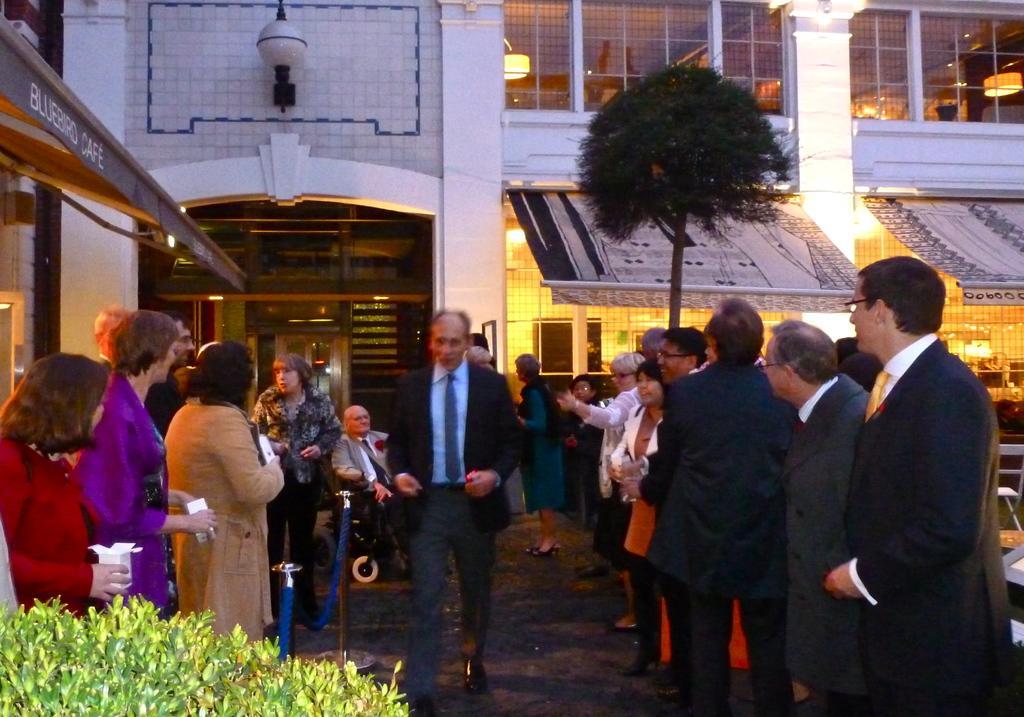Please provide a concise description of this image. In this picture we can see a group of people standing on the ground and a man sitting on a wheelchair, tree, sun shades, plants and in the background we can see a building with windows, lights. 